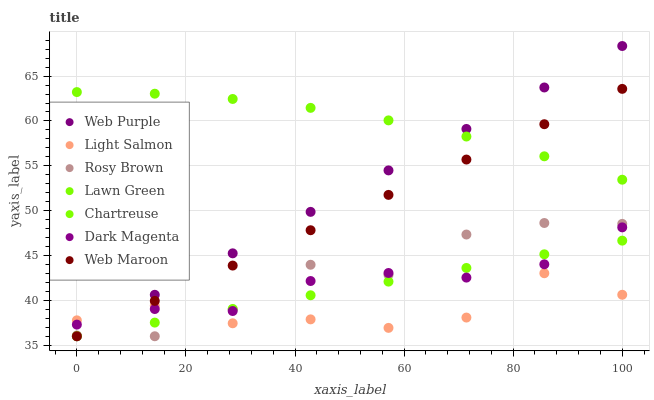Does Light Salmon have the minimum area under the curve?
Answer yes or no. Yes. Does Lawn Green have the maximum area under the curve?
Answer yes or no. Yes. Does Dark Magenta have the minimum area under the curve?
Answer yes or no. No. Does Dark Magenta have the maximum area under the curve?
Answer yes or no. No. Is Web Maroon the smoothest?
Answer yes or no. Yes. Is Rosy Brown the roughest?
Answer yes or no. Yes. Is Light Salmon the smoothest?
Answer yes or no. No. Is Light Salmon the roughest?
Answer yes or no. No. Does Rosy Brown have the lowest value?
Answer yes or no. Yes. Does Light Salmon have the lowest value?
Answer yes or no. No. Does Web Purple have the highest value?
Answer yes or no. Yes. Does Dark Magenta have the highest value?
Answer yes or no. No. Is Chartreuse less than Lawn Green?
Answer yes or no. Yes. Is Lawn Green greater than Chartreuse?
Answer yes or no. Yes. Does Light Salmon intersect Dark Magenta?
Answer yes or no. Yes. Is Light Salmon less than Dark Magenta?
Answer yes or no. No. Is Light Salmon greater than Dark Magenta?
Answer yes or no. No. Does Chartreuse intersect Lawn Green?
Answer yes or no. No. 